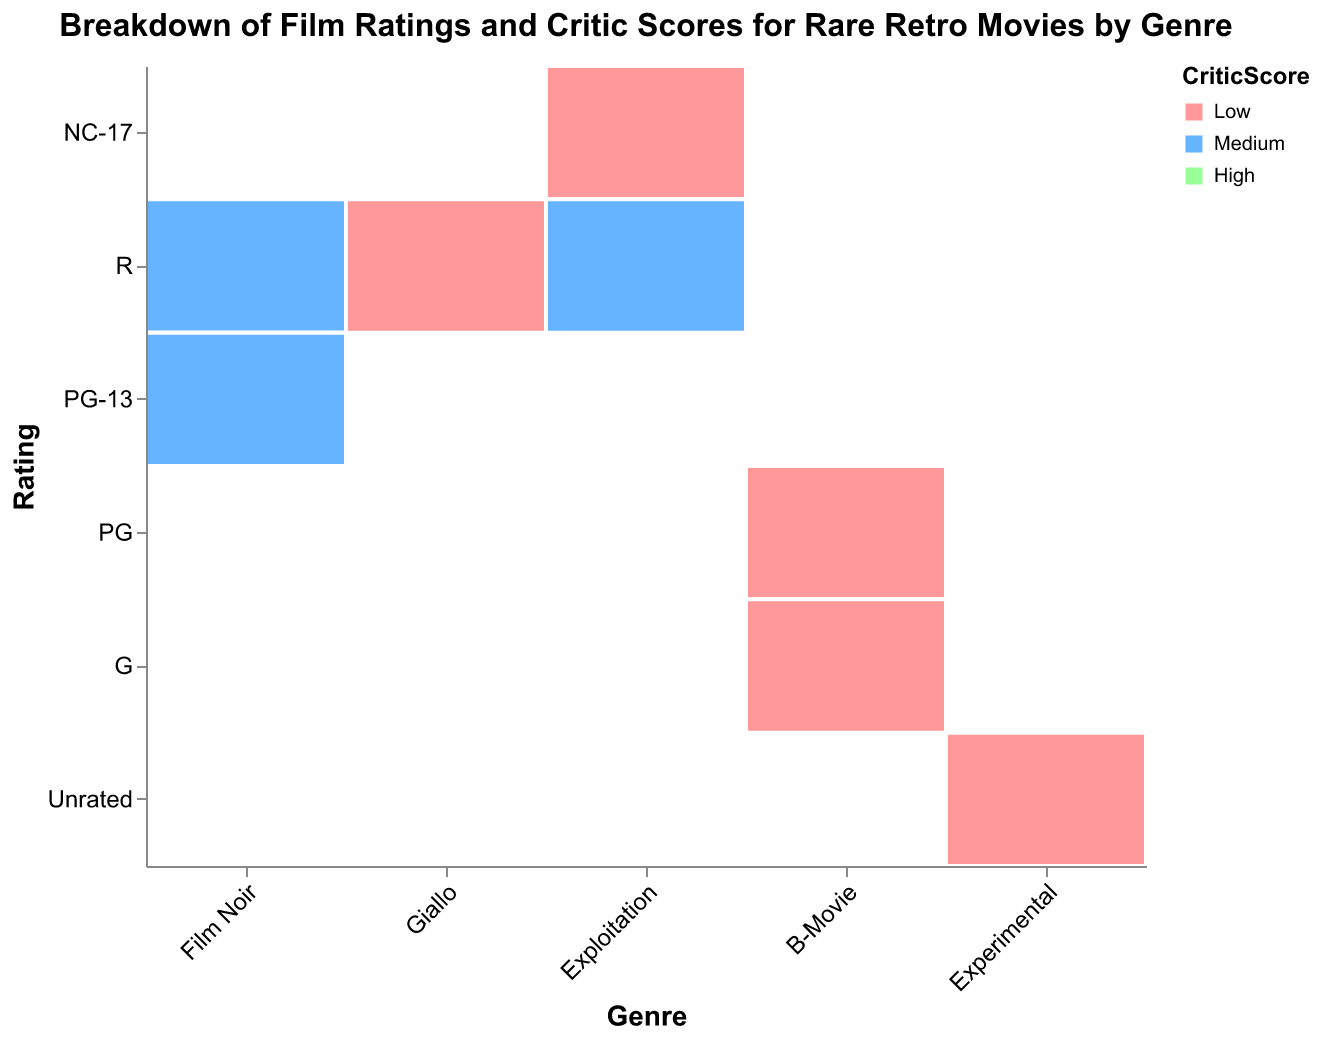What genre has the most movies with an 'R' rating? To determine which genre has the most movies with an 'R' rating, we look at all the rectangles corresponding to the 'R' rating on the y-axis. Then, summarize the counts for each genre. Film Noir has 15 (High) + 8 (Medium) = 23 and Giallo has 12 (High) + 10 (Medium) + 5 (Low) = 27, which is the highest among the genres.
Answer: Giallo Which rating has the highest count in the Experimental genre? Look at the 'Experimental' genre across all ratings on the y-axis. Compare the counts for each rating: Unrated High (9), Medium (7), and Low (5). The highest count is for Unrated High.
Answer: Unrated High How many movies in the B-Movie genre have a 'PG' rating? Check the B-Movie genre and look at the counts for 'PG' rating: Medium (11) + Low (14). Sum these counts to get the total number of movies. 11+14 = 25
Answer: 25 Compare the critic scores for Film Noir with an 'R' rating; which score is more frequent? For the 'R' rating in Film Noir, examine the counts for each critic score: High (15) and Medium (8). High has the larger count.
Answer: High What is the total number of 'NC-17' rated movies in the Exploitation genre? In the Exploitation genre, look at the 'NC-17' rating, and sum the counts for the Medium (7) and Low (9) critic scores. 7 + 9 = 16
Answer: 16 Which genre has the highest number of 'High' critic scores overall? Summarize the counts for High critic scores across all genres: Film Noir (15 + 6 = 21), Giallo (12), Exploitation (0), B-Movie (0), and Experimental (9). Film Noir has the highest total.
Answer: Film Noir Which combination of genre and rating has the lowest count? Identify the minimum count by examining each combination of genre and rating in the dataset. The lowest count observed is 4 for Film Noir with a PG-13 rating and Medium critic score.
Answer: Film Noir with PG-13 and Medium How does the count of unrated Experimental movies with a low critic score compare to those with a high critic score? Compare counts of Low and High critic scores within Experimental genre for Unrated rating: Low (5) and High (9). 5 is less than 9.
Answer: Less In the Giallo genre, which critic score category has more variety in ratings? Examine different ratings for each critic score category in Giallo. The High (only 'R'), Medium ('R'), and Low ('R'). Medium has more variety with 1 type.
Answer: Medium Which rating among all genres is entirely absent in this dataset? Analyze the ratings across all genre entries. All NC-17 and PG-13 ratings don't have a 'High' critic score; however, in this specific question context, the rating with zero count in any genre is NC-17 for the Experimental genre and Giallo, and PG-13 for Exploitation.
Answer: NC-17 and PG-13 